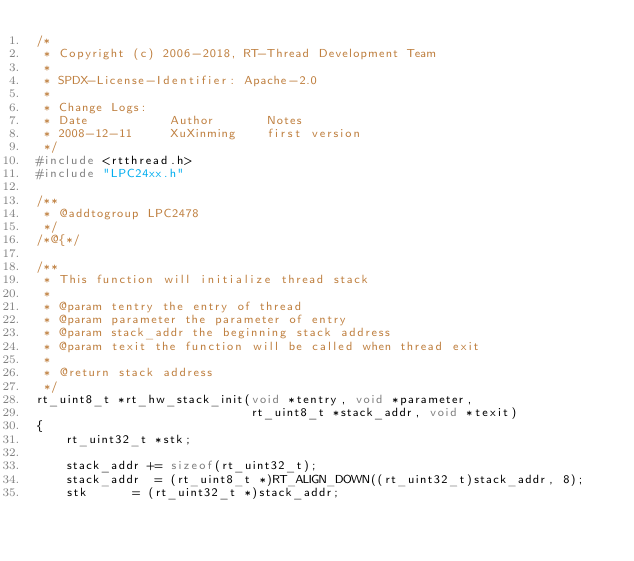Convert code to text. <code><loc_0><loc_0><loc_500><loc_500><_C_>/*
 * Copyright (c) 2006-2018, RT-Thread Development Team
 *
 * SPDX-License-Identifier: Apache-2.0
 *
 * Change Logs:
 * Date           Author       Notes
 * 2008-12-11     XuXinming    first version
 */
#include <rtthread.h>
#include "LPC24xx.h"

/**
 * @addtogroup LPC2478
 */
/*@{*/

/**
 * This function will initialize thread stack
 *
 * @param tentry the entry of thread
 * @param parameter the parameter of entry
 * @param stack_addr the beginning stack address
 * @param texit the function will be called when thread exit
 *
 * @return stack address
 */
rt_uint8_t *rt_hw_stack_init(void *tentry, void *parameter,
                             rt_uint8_t *stack_addr, void *texit)
{
    rt_uint32_t *stk;

    stack_addr += sizeof(rt_uint32_t);
    stack_addr  = (rt_uint8_t *)RT_ALIGN_DOWN((rt_uint32_t)stack_addr, 8);
    stk      = (rt_uint32_t *)stack_addr;
</code> 